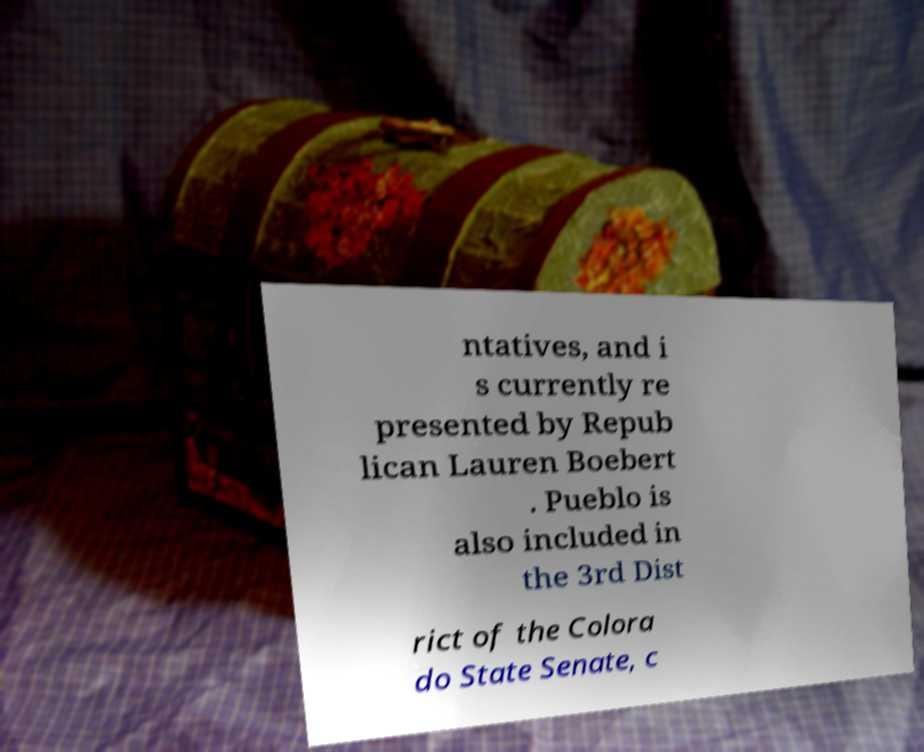Can you read and provide the text displayed in the image?This photo seems to have some interesting text. Can you extract and type it out for me? ntatives, and i s currently re presented by Repub lican Lauren Boebert . Pueblo is also included in the 3rd Dist rict of the Colora do State Senate, c 